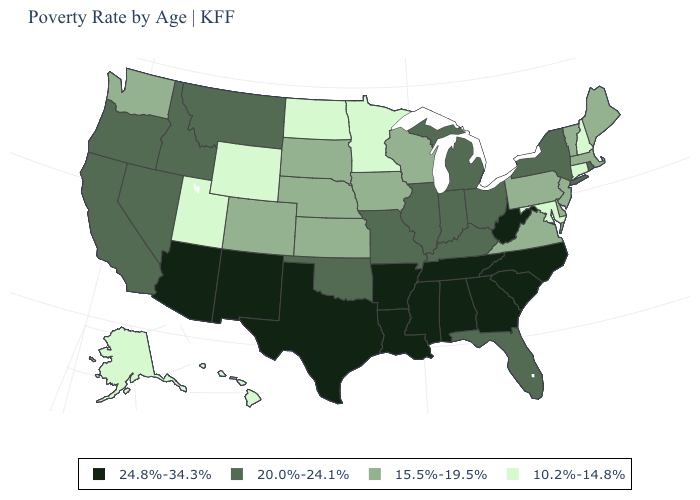What is the value of New Hampshire?
Answer briefly. 10.2%-14.8%. How many symbols are there in the legend?
Concise answer only. 4. What is the highest value in the MidWest ?
Be succinct. 20.0%-24.1%. What is the value of Georgia?
Write a very short answer. 24.8%-34.3%. What is the lowest value in states that border Colorado?
Quick response, please. 10.2%-14.8%. What is the value of Vermont?
Concise answer only. 15.5%-19.5%. Is the legend a continuous bar?
Concise answer only. No. Does the map have missing data?
Be succinct. No. Name the states that have a value in the range 20.0%-24.1%?
Write a very short answer. California, Florida, Idaho, Illinois, Indiana, Kentucky, Michigan, Missouri, Montana, Nevada, New York, Ohio, Oklahoma, Oregon, Rhode Island. Does Indiana have a higher value than Louisiana?
Keep it brief. No. Does the map have missing data?
Keep it brief. No. Which states have the lowest value in the West?
Write a very short answer. Alaska, Hawaii, Utah, Wyoming. Is the legend a continuous bar?
Answer briefly. No. What is the lowest value in the USA?
Be succinct. 10.2%-14.8%. Which states have the highest value in the USA?
Give a very brief answer. Alabama, Arizona, Arkansas, Georgia, Louisiana, Mississippi, New Mexico, North Carolina, South Carolina, Tennessee, Texas, West Virginia. 